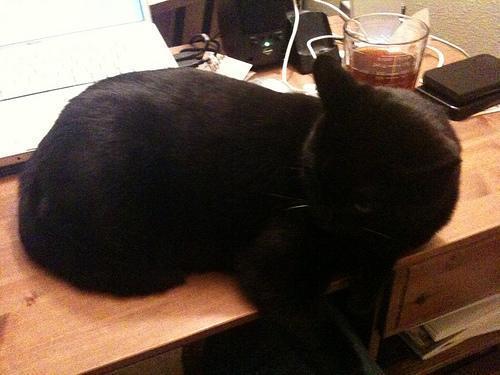How many cats are there?
Give a very brief answer. 1. 